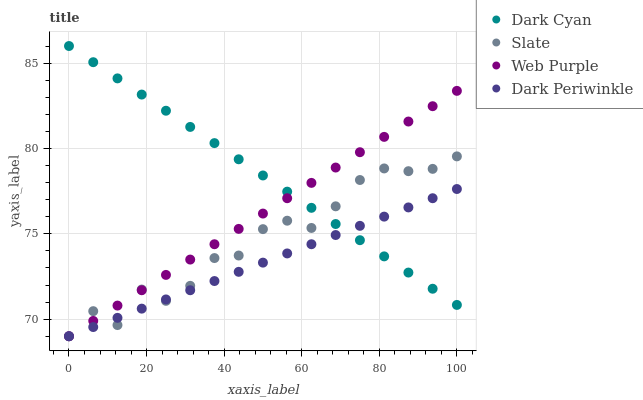Does Dark Periwinkle have the minimum area under the curve?
Answer yes or no. Yes. Does Dark Cyan have the maximum area under the curve?
Answer yes or no. Yes. Does Slate have the minimum area under the curve?
Answer yes or no. No. Does Slate have the maximum area under the curve?
Answer yes or no. No. Is Dark Cyan the smoothest?
Answer yes or no. Yes. Is Slate the roughest?
Answer yes or no. Yes. Is Web Purple the smoothest?
Answer yes or no. No. Is Web Purple the roughest?
Answer yes or no. No. Does Slate have the lowest value?
Answer yes or no. Yes. Does Dark Cyan have the highest value?
Answer yes or no. Yes. Does Slate have the highest value?
Answer yes or no. No. Does Dark Periwinkle intersect Slate?
Answer yes or no. Yes. Is Dark Periwinkle less than Slate?
Answer yes or no. No. Is Dark Periwinkle greater than Slate?
Answer yes or no. No. 